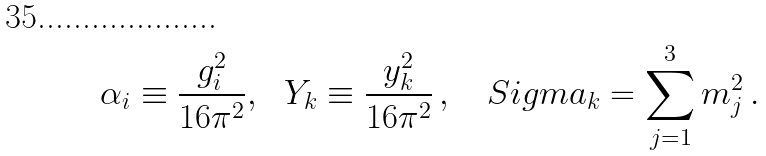<formula> <loc_0><loc_0><loc_500><loc_500>\alpha _ { i } \equiv \frac { g _ { i } ^ { 2 } } { 1 6 \pi ^ { 2 } } , \ \ Y _ { k } \equiv \frac { y _ { k } ^ { 2 } } { 1 6 \pi ^ { 2 } } \, , \ \ \ S i g m a _ { k } = \sum _ { j = 1 } ^ { 3 } m ^ { 2 } _ { j } \, .</formula> 